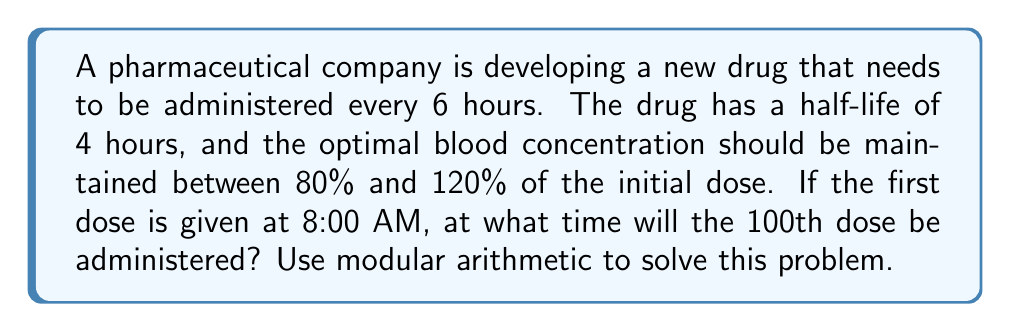Solve this math problem. To solve this problem, we'll use modular arithmetic to determine the timing of the 100th dose:

1) First, let's establish our modulus. Since the drug is administered every 6 hours, we'll use a modulus of 24 (hours in a day):

   $$6 \equiv 6 \pmod{24}$$

2) Now, let's calculate how many hours will have passed by the 100th dose:

   $$100 \text{ doses} \times 6 \text{ hours} = 600 \text{ hours}$$

3) We can use the modular arithmetic operation to find out how many hours this is equivalent to within a 24-hour cycle:

   $$600 \equiv x \pmod{24}$$

4) To solve this, we can divide 600 by 24:

   $$600 = 24 \times 25 + 0$$

   Therefore, $$600 \equiv 0 \pmod{24}$$

5) This means that after 600 hours, we're back at the same time of day we started.

6) Since we started at 8:00 AM, the 100th dose will also be at 8:00 AM.

To verify:
- 99 doses will take 594 hours (99 * 6 = 594)
- 594 hours = 24 days + 18 hours
- 18 hours after 8:00 AM is 2:00 AM
- The next dose (100th) will be 6 hours later, at 8:00 AM

This method ensures precise timing for FDA submissions, maintaining optimal blood concentration levels for drug efficacy and safety.
Answer: The 100th dose will be administered at 8:00 AM. 